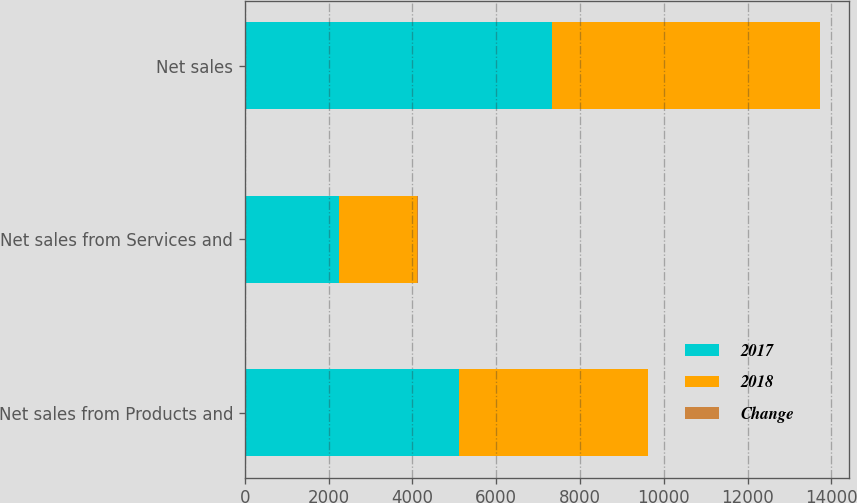<chart> <loc_0><loc_0><loc_500><loc_500><stacked_bar_chart><ecel><fcel>Net sales from Products and<fcel>Net sales from Services and<fcel>Net sales<nl><fcel>2017<fcel>5100<fcel>2243<fcel>7343<nl><fcel>2018<fcel>4513<fcel>1867<fcel>6380<nl><fcel>Change<fcel>13<fcel>20<fcel>15<nl></chart> 